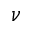<formula> <loc_0><loc_0><loc_500><loc_500>\nu</formula> 